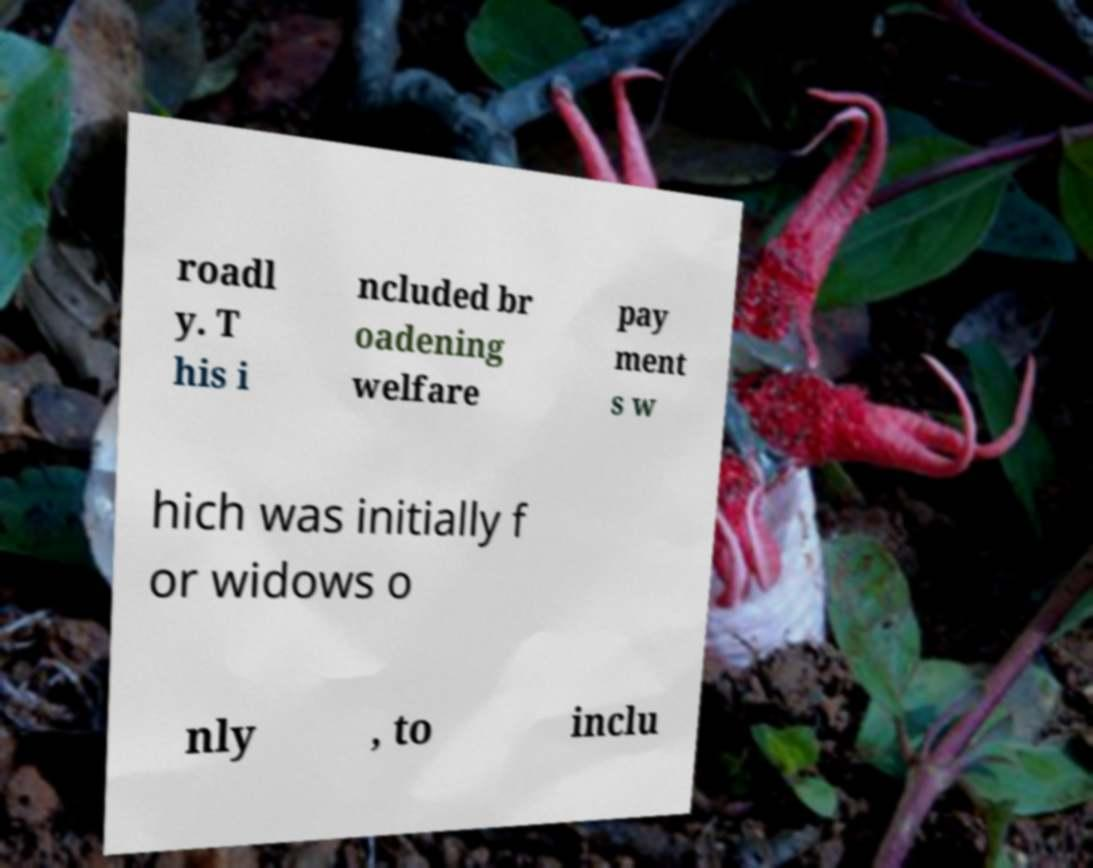Could you assist in decoding the text presented in this image and type it out clearly? roadl y. T his i ncluded br oadening welfare pay ment s w hich was initially f or widows o nly , to inclu 